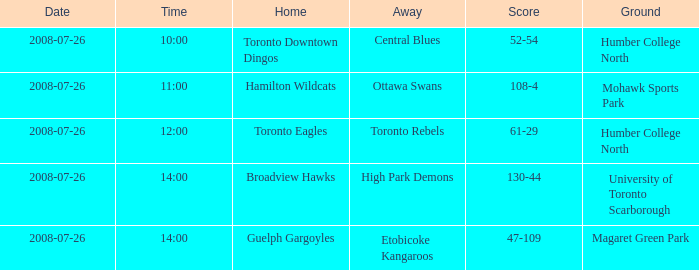The away high park demons was at which field? University of Toronto Scarborough. 